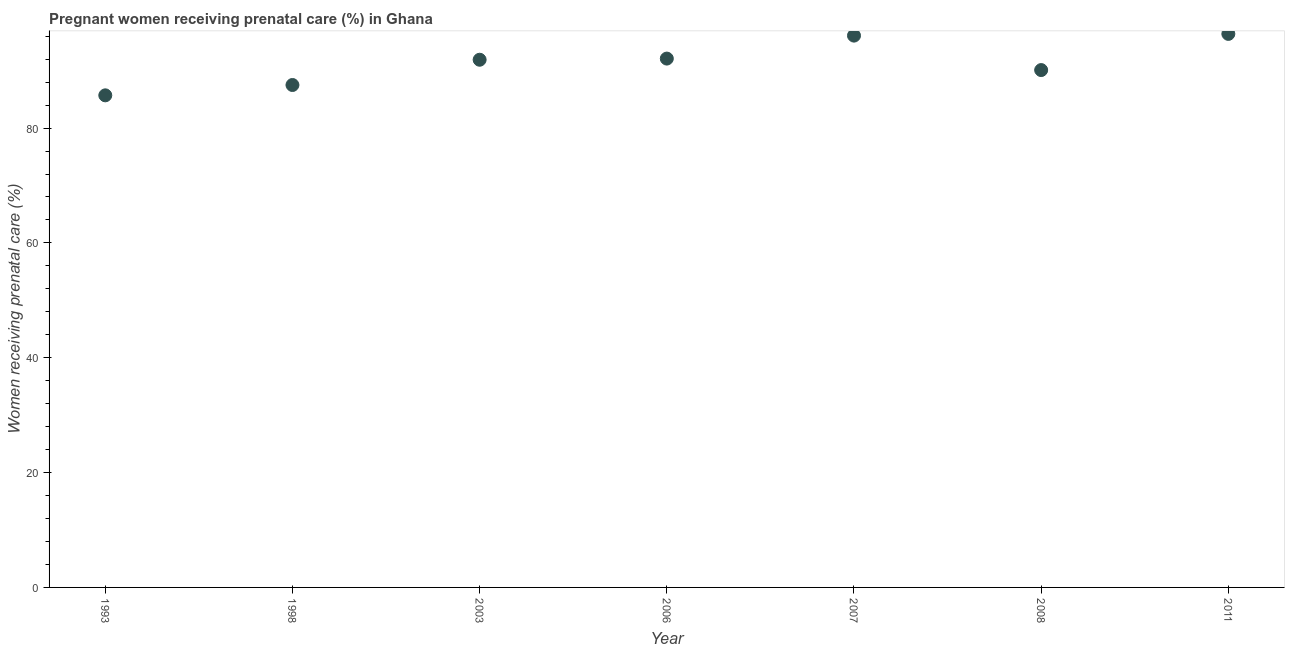What is the percentage of pregnant women receiving prenatal care in 2008?
Offer a very short reply. 90.1. Across all years, what is the maximum percentage of pregnant women receiving prenatal care?
Offer a terse response. 96.4. Across all years, what is the minimum percentage of pregnant women receiving prenatal care?
Your answer should be very brief. 85.7. In which year was the percentage of pregnant women receiving prenatal care maximum?
Offer a terse response. 2011. What is the sum of the percentage of pregnant women receiving prenatal care?
Provide a succinct answer. 639.8. What is the difference between the percentage of pregnant women receiving prenatal care in 2007 and 2011?
Provide a short and direct response. -0.3. What is the average percentage of pregnant women receiving prenatal care per year?
Your answer should be very brief. 91.4. What is the median percentage of pregnant women receiving prenatal care?
Offer a terse response. 91.9. What is the ratio of the percentage of pregnant women receiving prenatal care in 2007 to that in 2008?
Provide a short and direct response. 1.07. Is the percentage of pregnant women receiving prenatal care in 1998 less than that in 2011?
Your answer should be compact. Yes. What is the difference between the highest and the second highest percentage of pregnant women receiving prenatal care?
Keep it short and to the point. 0.3. Is the sum of the percentage of pregnant women receiving prenatal care in 2003 and 2006 greater than the maximum percentage of pregnant women receiving prenatal care across all years?
Give a very brief answer. Yes. What is the difference between the highest and the lowest percentage of pregnant women receiving prenatal care?
Ensure brevity in your answer.  10.7. Does the percentage of pregnant women receiving prenatal care monotonically increase over the years?
Your answer should be compact. No. How many dotlines are there?
Ensure brevity in your answer.  1. How many years are there in the graph?
Give a very brief answer. 7. What is the difference between two consecutive major ticks on the Y-axis?
Ensure brevity in your answer.  20. Does the graph contain any zero values?
Offer a very short reply. No. What is the title of the graph?
Your answer should be compact. Pregnant women receiving prenatal care (%) in Ghana. What is the label or title of the Y-axis?
Your answer should be very brief. Women receiving prenatal care (%). What is the Women receiving prenatal care (%) in 1993?
Offer a terse response. 85.7. What is the Women receiving prenatal care (%) in 1998?
Your answer should be very brief. 87.5. What is the Women receiving prenatal care (%) in 2003?
Keep it short and to the point. 91.9. What is the Women receiving prenatal care (%) in 2006?
Your answer should be very brief. 92.1. What is the Women receiving prenatal care (%) in 2007?
Your answer should be compact. 96.1. What is the Women receiving prenatal care (%) in 2008?
Make the answer very short. 90.1. What is the Women receiving prenatal care (%) in 2011?
Provide a short and direct response. 96.4. What is the difference between the Women receiving prenatal care (%) in 1993 and 2003?
Your answer should be very brief. -6.2. What is the difference between the Women receiving prenatal care (%) in 1998 and 2006?
Your answer should be compact. -4.6. What is the difference between the Women receiving prenatal care (%) in 1998 and 2007?
Offer a terse response. -8.6. What is the difference between the Women receiving prenatal care (%) in 1998 and 2011?
Your answer should be very brief. -8.9. What is the difference between the Women receiving prenatal care (%) in 2003 and 2006?
Provide a succinct answer. -0.2. What is the difference between the Women receiving prenatal care (%) in 2003 and 2007?
Provide a succinct answer. -4.2. What is the difference between the Women receiving prenatal care (%) in 2003 and 2008?
Offer a terse response. 1.8. What is the difference between the Women receiving prenatal care (%) in 2006 and 2008?
Provide a succinct answer. 2. What is the difference between the Women receiving prenatal care (%) in 2007 and 2008?
Keep it short and to the point. 6. What is the difference between the Women receiving prenatal care (%) in 2008 and 2011?
Offer a terse response. -6.3. What is the ratio of the Women receiving prenatal care (%) in 1993 to that in 2003?
Provide a succinct answer. 0.93. What is the ratio of the Women receiving prenatal care (%) in 1993 to that in 2007?
Make the answer very short. 0.89. What is the ratio of the Women receiving prenatal care (%) in 1993 to that in 2008?
Provide a short and direct response. 0.95. What is the ratio of the Women receiving prenatal care (%) in 1993 to that in 2011?
Offer a very short reply. 0.89. What is the ratio of the Women receiving prenatal care (%) in 1998 to that in 2006?
Your answer should be very brief. 0.95. What is the ratio of the Women receiving prenatal care (%) in 1998 to that in 2007?
Give a very brief answer. 0.91. What is the ratio of the Women receiving prenatal care (%) in 1998 to that in 2011?
Provide a short and direct response. 0.91. What is the ratio of the Women receiving prenatal care (%) in 2003 to that in 2006?
Your response must be concise. 1. What is the ratio of the Women receiving prenatal care (%) in 2003 to that in 2007?
Ensure brevity in your answer.  0.96. What is the ratio of the Women receiving prenatal care (%) in 2003 to that in 2008?
Make the answer very short. 1.02. What is the ratio of the Women receiving prenatal care (%) in 2003 to that in 2011?
Provide a short and direct response. 0.95. What is the ratio of the Women receiving prenatal care (%) in 2006 to that in 2007?
Ensure brevity in your answer.  0.96. What is the ratio of the Women receiving prenatal care (%) in 2006 to that in 2011?
Give a very brief answer. 0.95. What is the ratio of the Women receiving prenatal care (%) in 2007 to that in 2008?
Ensure brevity in your answer.  1.07. What is the ratio of the Women receiving prenatal care (%) in 2008 to that in 2011?
Your answer should be very brief. 0.94. 